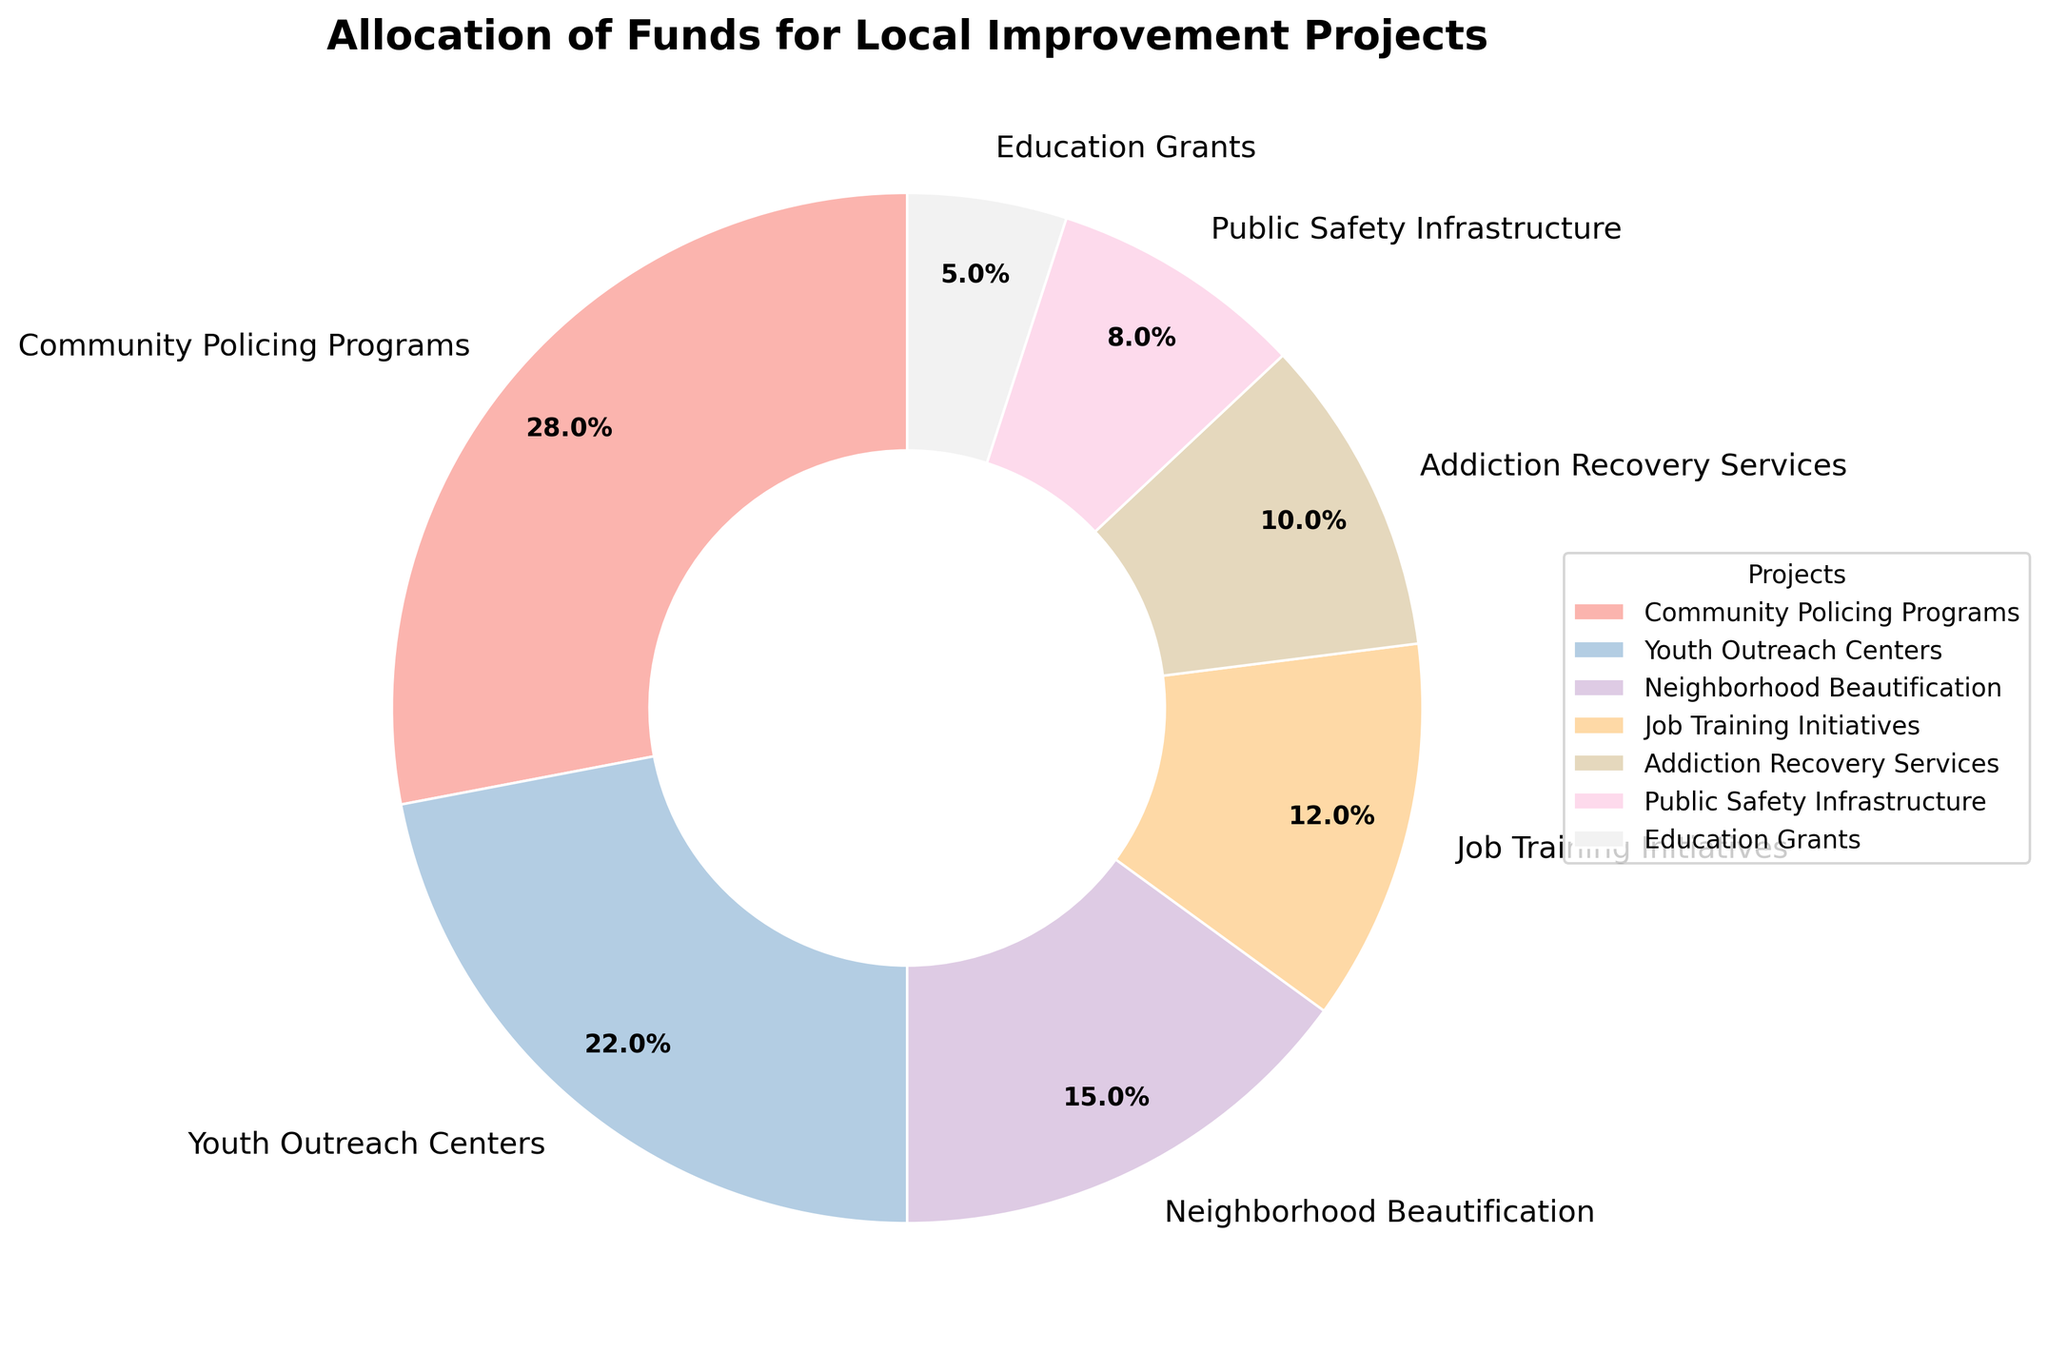Which project received the highest percentage of funds? From the pie chart, it is observed that the largest wedge represents the Community Policing Programs with a percentage of 28%. This percentage is the highest among all the listed projects.
Answer: Community Policing Programs How much more funding did the Community Policing Programs receive compared to the Youth Outreach Centers? The Community Policing Programs received 28% of the funds, while the Youth Outreach Centers received 22%. The difference between these percentages is 28% - 22% = 6%.
Answer: 6% What is the combined percentage of funds allocated to Neighborhood Beautification and Education Grants? The pie chart shows that Neighborhood Beautification received 15% of the funds and Education Grants received 5%. Adding these percentages gives 15% + 5% = 20%.
Answer: 20% Which project received the least percentage of the funds and what percentage is it? From the pie chart, Education Grants received the smallest wedge, indicating the least percentage of 5%.
Answer: Education Grants, 5% Are the funds allocated to Addiction Recovery Services higher or lower than the funds for Job Training Initiatives? The pie chart shows Addiction Recovery Services received 10%, whereas Job Training Initiatives received 12%. Comparing these, 10% is lower than 12%.
Answer: Lower How do the percentages of Community Policing Programs and Public Safety Infrastructure together compare to Youth Outreach Centers? Community Policing Programs received 28% and Public Safety Infrastructure received 8%. Combining these, 28% + 8% = 36%. Youth Outreach Centers received 22%, so 36% is greater than 22%.
Answer: Greater Is the share of funds for Job Training Initiatives greater than the combined share for Addiction Recovery Services and Education Grants? Job Training Initiatives have 12% of the funds. Addiction Recovery Services and Education Grants together have 10% + 5% = 15%. So, 12% is less than 15%.
Answer: Less Which project received just over one-fifth (around 20%) of the total funds? The pie chart shows that Youth Outreach Centers received 22% of the total funds, which is just over one-fifth of the total (20%).
Answer: Youth Outreach Centers How many projects received less than 10% funding each, and can you name them? The pie chart shows that Public Safety Infrastructure received 8% and Education Grants received 5%, both of which are less than 10%. These projects are Public Safety Infrastructure and Education Grants.
Answer: 2, Public Safety Infrastructure and Education Grants 